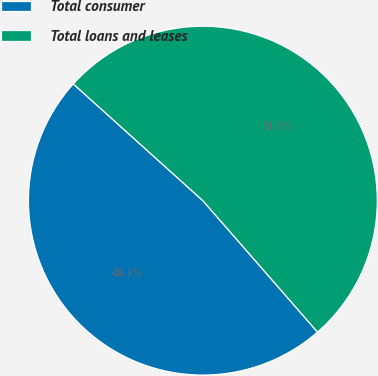Convert chart. <chart><loc_0><loc_0><loc_500><loc_500><pie_chart><fcel>Total consumer<fcel>Total loans and leases<nl><fcel>48.09%<fcel>51.91%<nl></chart> 